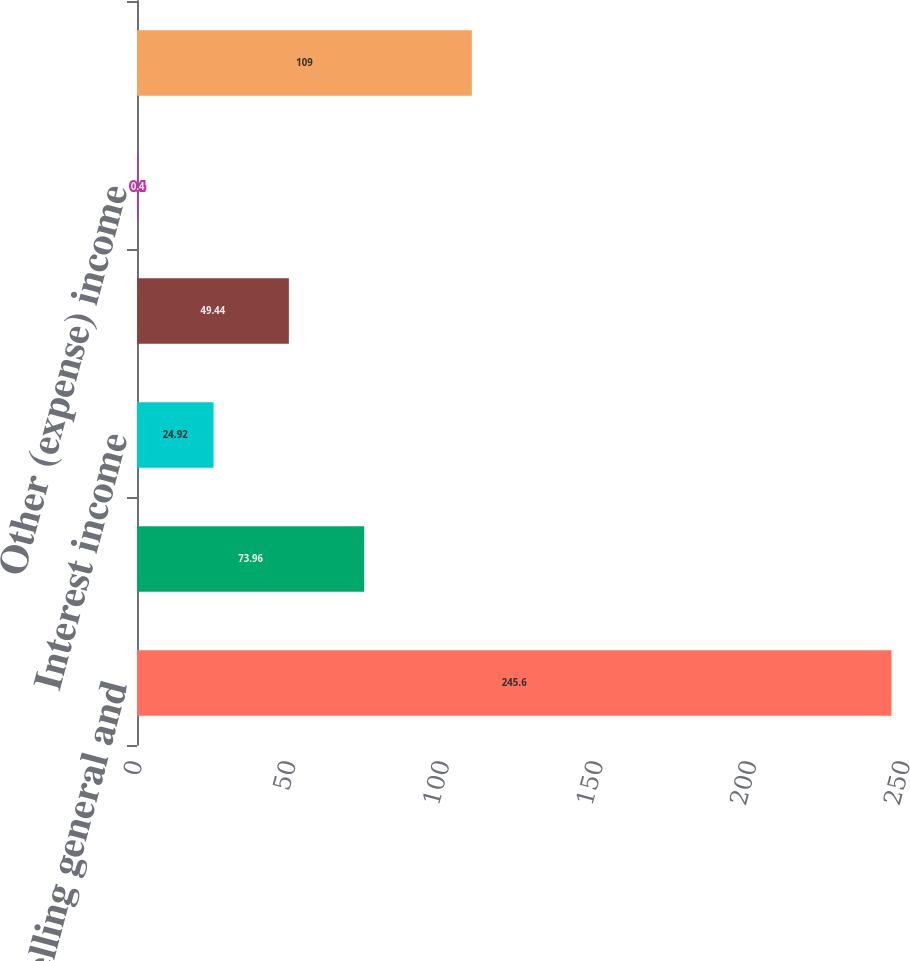Convert chart to OTSL. <chart><loc_0><loc_0><loc_500><loc_500><bar_chart><fcel>Selling general and<fcel>Other operating expenses<fcel>Interest income<fcel>Foreign currency transaction<fcel>Other (expense) income<fcel>Provision for income taxes<nl><fcel>245.6<fcel>73.96<fcel>24.92<fcel>49.44<fcel>0.4<fcel>109<nl></chart> 